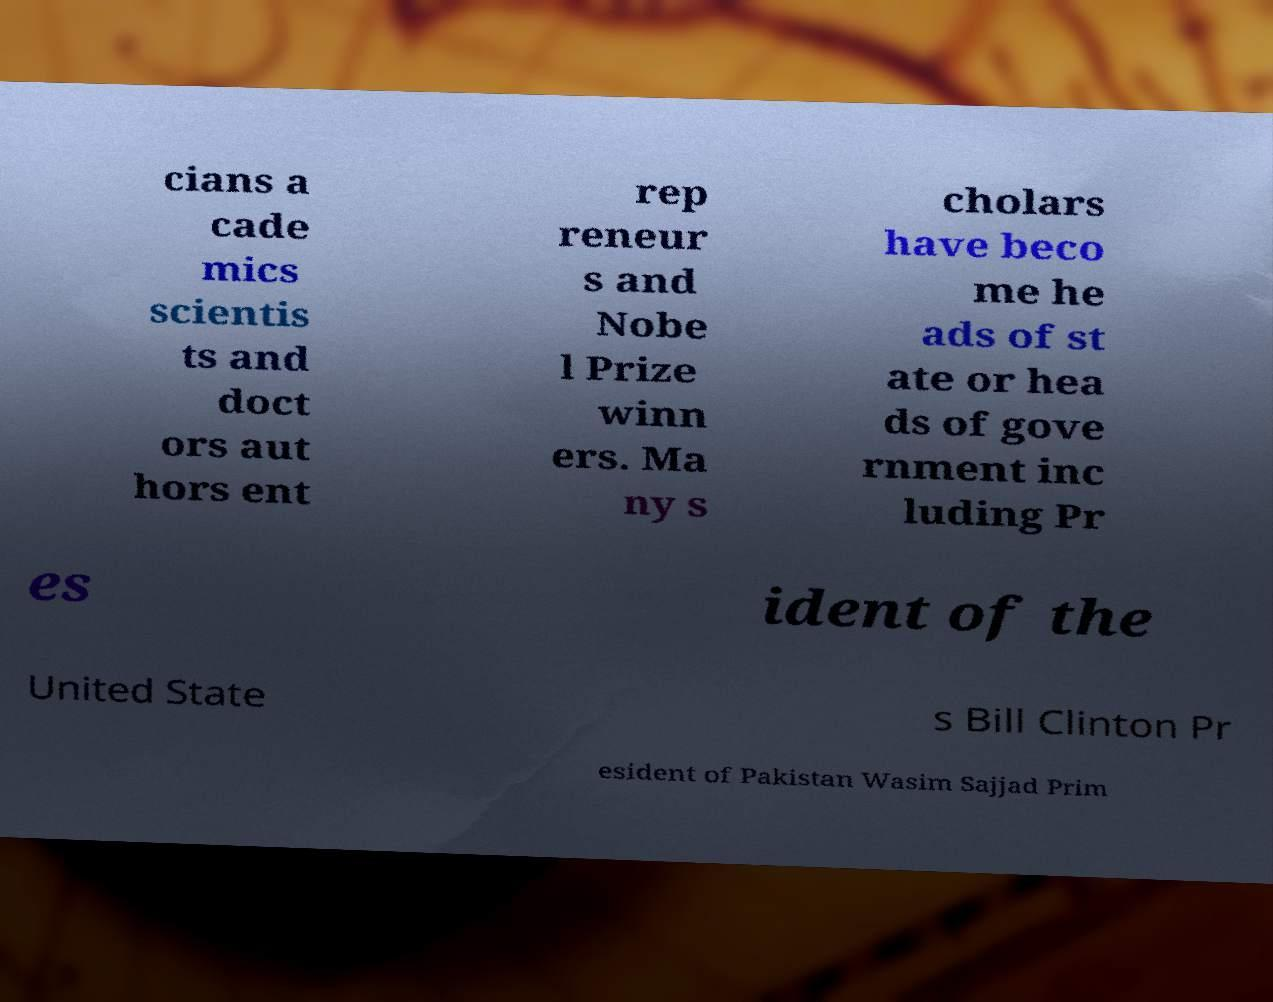I need the written content from this picture converted into text. Can you do that? cians a cade mics scientis ts and doct ors aut hors ent rep reneur s and Nobe l Prize winn ers. Ma ny s cholars have beco me he ads of st ate or hea ds of gove rnment inc luding Pr es ident of the United State s Bill Clinton Pr esident of Pakistan Wasim Sajjad Prim 